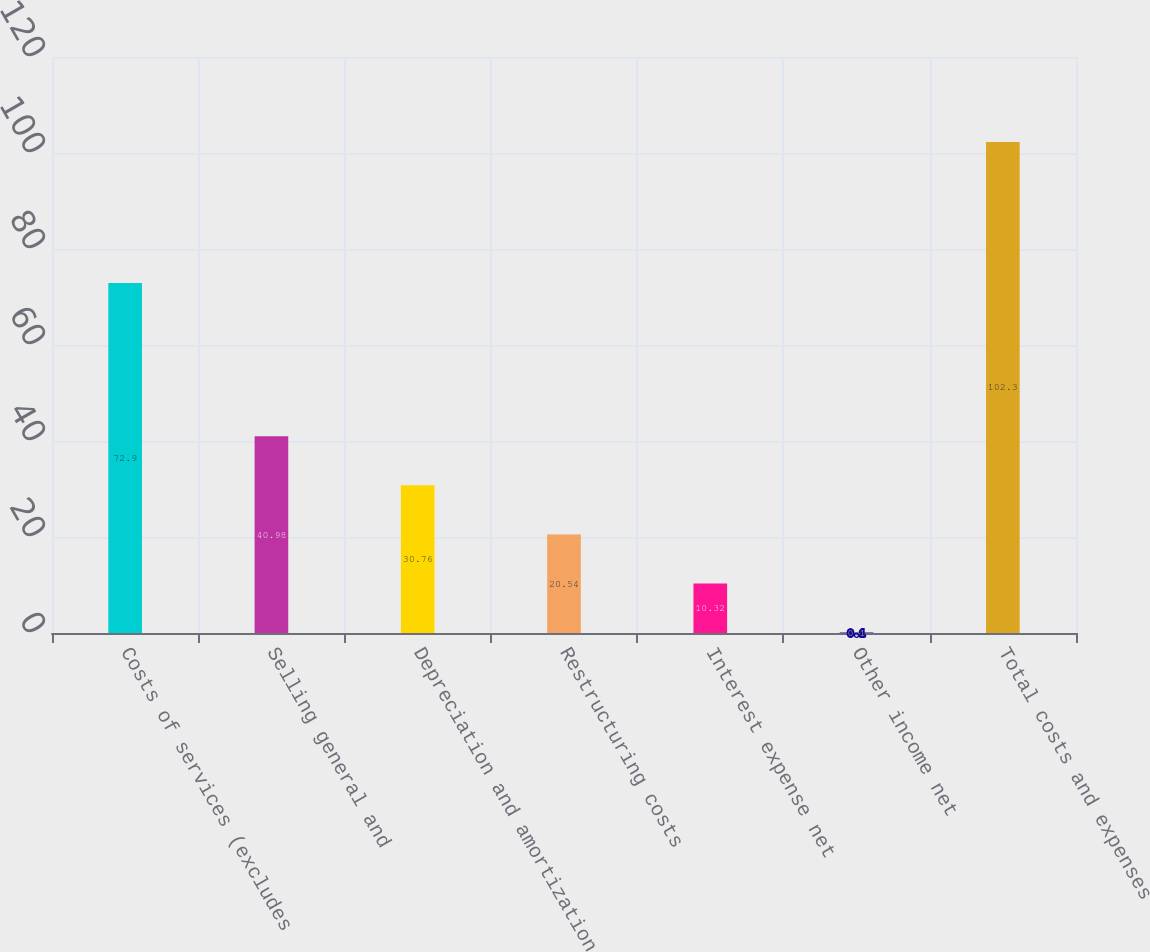<chart> <loc_0><loc_0><loc_500><loc_500><bar_chart><fcel>Costs of services (excludes<fcel>Selling general and<fcel>Depreciation and amortization<fcel>Restructuring costs<fcel>Interest expense net<fcel>Other income net<fcel>Total costs and expenses<nl><fcel>72.9<fcel>40.98<fcel>30.76<fcel>20.54<fcel>10.32<fcel>0.1<fcel>102.3<nl></chart> 